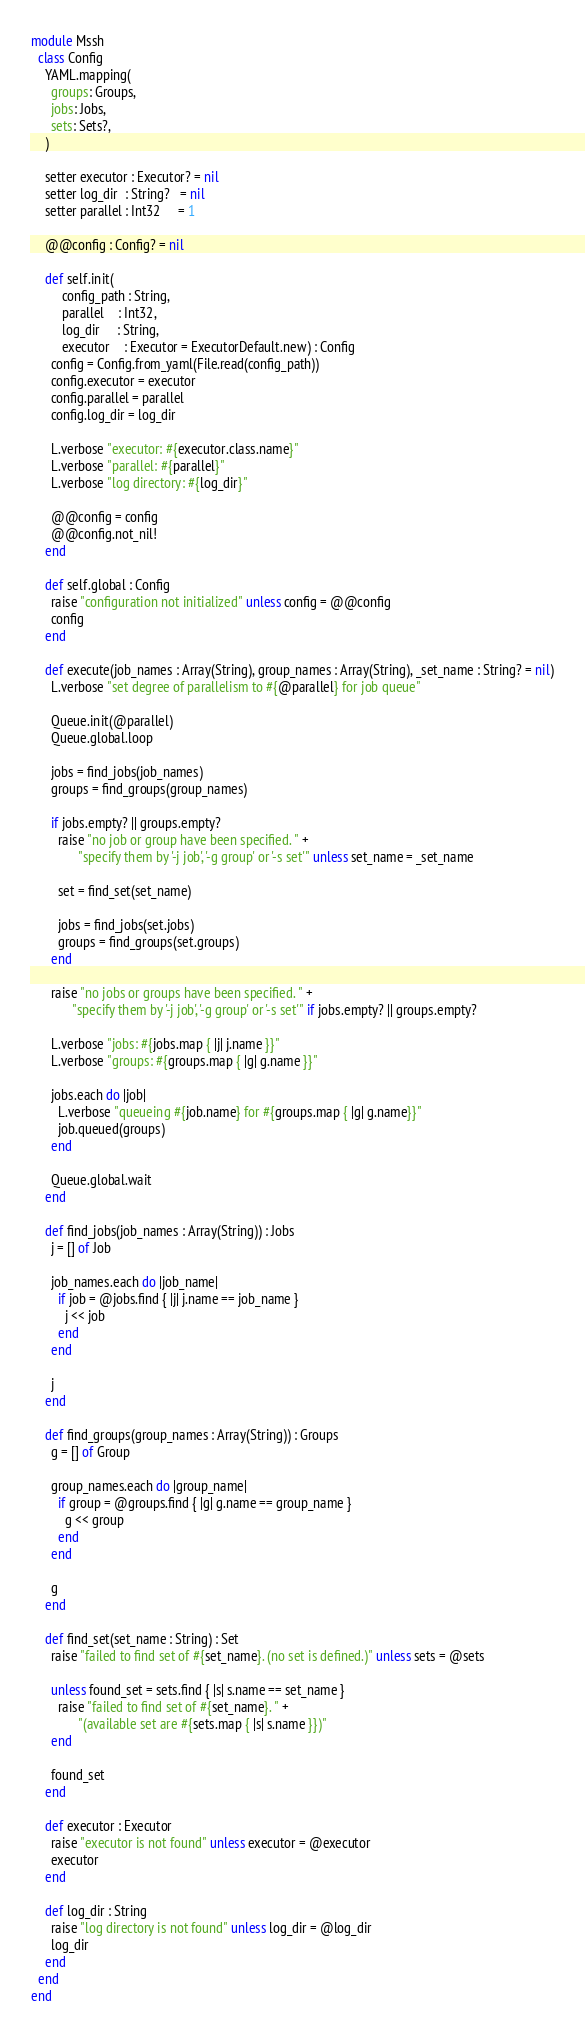<code> <loc_0><loc_0><loc_500><loc_500><_Crystal_>module Mssh
  class Config
    YAML.mapping(
      groups: Groups,
      jobs: Jobs,
      sets: Sets?,
    )

    setter executor : Executor? = nil
    setter log_dir  : String?   = nil
    setter parallel : Int32     = 1

    @@config : Config? = nil

    def self.init(
         config_path : String,
         parallel    : Int32,
         log_dir     : String,
         executor    : Executor = ExecutorDefault.new) : Config
      config = Config.from_yaml(File.read(config_path))
      config.executor = executor
      config.parallel = parallel
      config.log_dir = log_dir

      L.verbose "executor: #{executor.class.name}"
      L.verbose "parallel: #{parallel}"
      L.verbose "log directory: #{log_dir}"

      @@config = config
      @@config.not_nil!
    end

    def self.global : Config
      raise "configuration not initialized" unless config = @@config
      config
    end

    def execute(job_names : Array(String), group_names : Array(String), _set_name : String? = nil)
      L.verbose "set degree of parallelism to #{@parallel} for job queue"

      Queue.init(@parallel)
      Queue.global.loop

      jobs = find_jobs(job_names)
      groups = find_groups(group_names)

      if jobs.empty? || groups.empty?
        raise "no job or group have been specified. " +
              "specify them by '-j job', '-g group' or '-s set'" unless set_name = _set_name

        set = find_set(set_name)

        jobs = find_jobs(set.jobs)
        groups = find_groups(set.groups)
      end

      raise "no jobs or groups have been specified. " +
            "specify them by '-j job', '-g group' or '-s set'" if jobs.empty? || groups.empty?

      L.verbose "jobs: #{jobs.map { |j| j.name }}"
      L.verbose "groups: #{groups.map { |g| g.name }}"

      jobs.each do |job|
        L.verbose "queueing #{job.name} for #{groups.map { |g| g.name}}"
        job.queued(groups)
      end

      Queue.global.wait
    end

    def find_jobs(job_names : Array(String)) : Jobs
      j = [] of Job

      job_names.each do |job_name|
        if job = @jobs.find { |j| j.name == job_name }
          j << job
        end
      end

      j
    end

    def find_groups(group_names : Array(String)) : Groups
      g = [] of Group

      group_names.each do |group_name|
        if group = @groups.find { |g| g.name == group_name }
          g << group
        end
      end

      g
    end

    def find_set(set_name : String) : Set
      raise "failed to find set of #{set_name}. (no set is defined.)" unless sets = @sets

      unless found_set = sets.find { |s| s.name == set_name }
        raise "failed to find set of #{set_name}. " +
              "(available set are #{sets.map { |s| s.name }})"
      end

      found_set
    end

    def executor : Executor
      raise "executor is not found" unless executor = @executor
      executor
    end

    def log_dir : String
      raise "log directory is not found" unless log_dir = @log_dir
      log_dir
    end
  end
end
</code> 